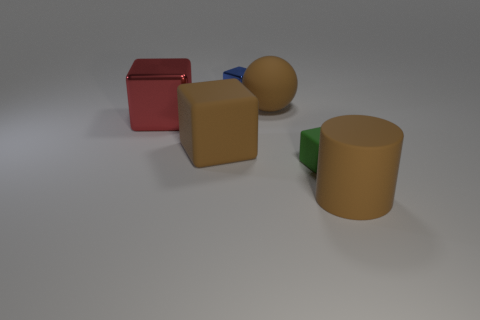There is a tiny blue metallic thing; how many tiny green things are in front of it?
Ensure brevity in your answer.  1. There is a red object that is the same shape as the small blue metallic object; what is its size?
Your answer should be compact. Large. How big is the rubber thing that is in front of the brown rubber block and to the left of the brown rubber cylinder?
Offer a very short reply. Small. Do the cylinder and the rubber thing that is on the left side of the matte ball have the same color?
Give a very brief answer. Yes. What number of red things are either rubber cylinders or cubes?
Ensure brevity in your answer.  1. What is the shape of the big metallic thing?
Offer a terse response. Cube. What number of other things are there of the same shape as the large red object?
Provide a succinct answer. 3. There is a thing that is in front of the tiny green rubber object; what is its color?
Your answer should be very brief. Brown. Are the small green thing and the ball made of the same material?
Offer a very short reply. Yes. How many things are either tiny green objects or large things in front of the green thing?
Offer a terse response. 2. 